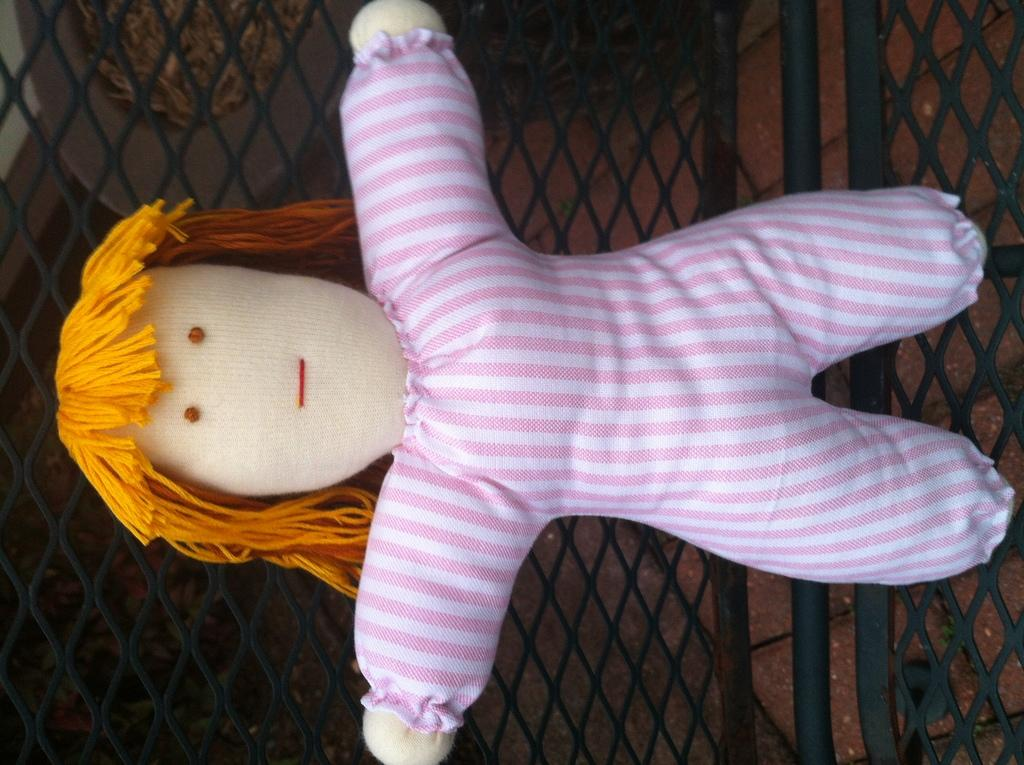What is the main object in the image? There is a pumpkin in the image. Where is the pumpkin located? The pumpkin is placed on a grill. Can you describe the position of the pumpkin in the image? The pumpkin is in the center of the image. What type of insurance policy is being discussed in the image? There is no discussion of insurance in the image; it features a pumpkin on a grill. Can you tell me how many needles are present in the image? There are no needles present in the image; it features a pumpkin on a grill. 